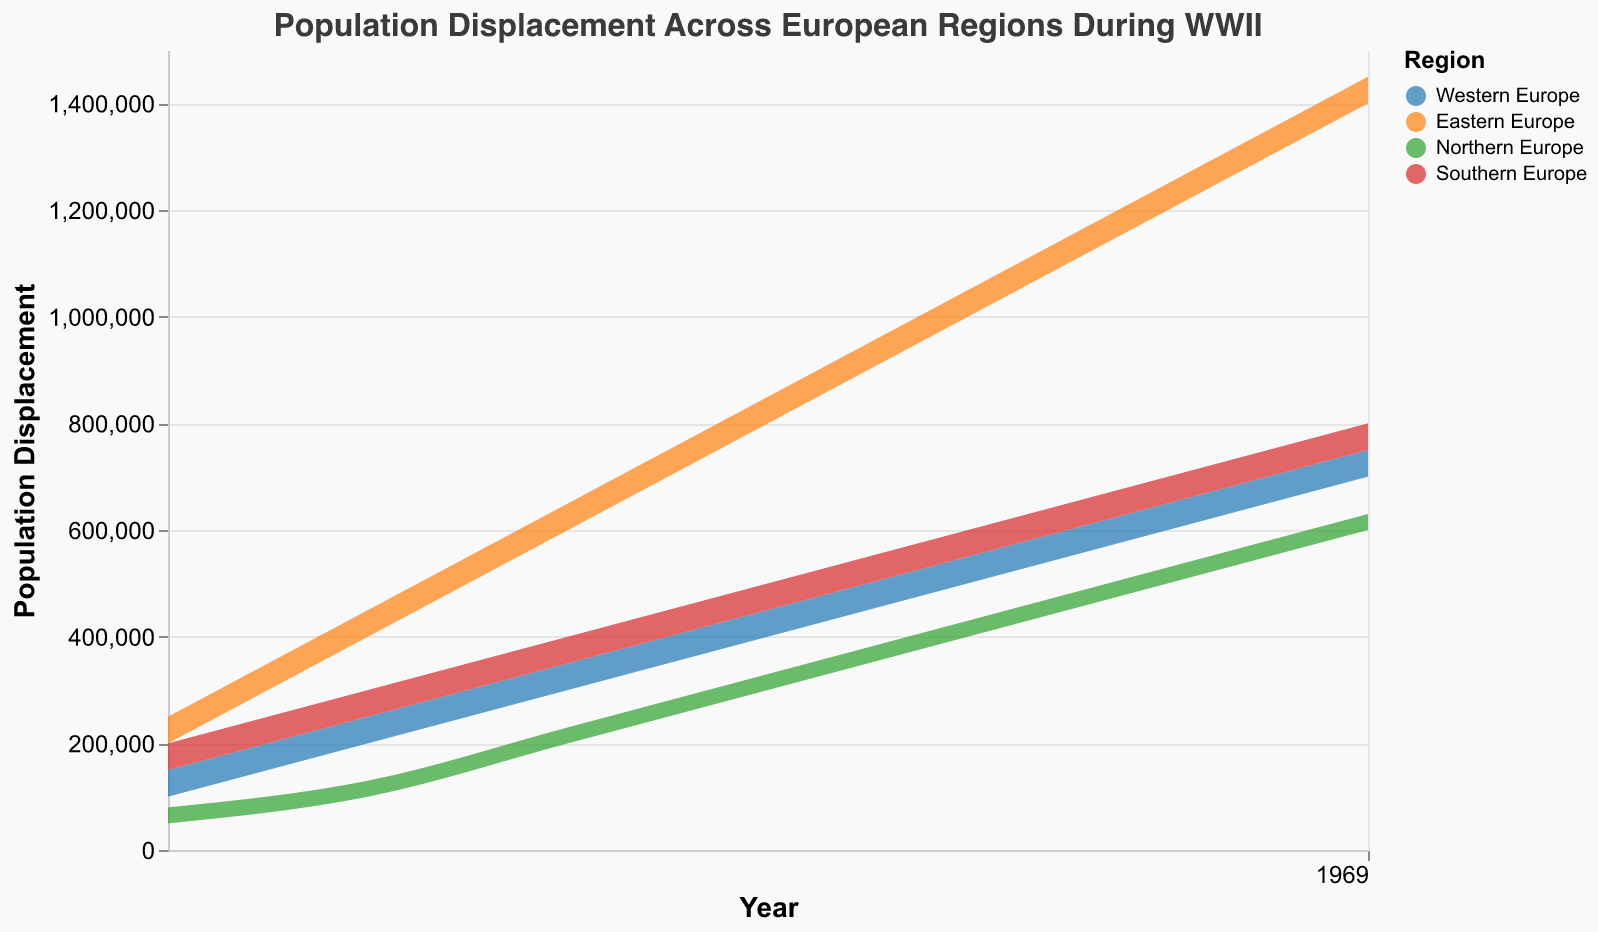What is the title of the figure? The title is usually placed at the top of the chart to give a brief description of what the chart represents. In this case, the title is "Population Displacement Across European Regions During WWII".
Answer: Population Displacement Across European Regions During WWII How many regions are represented in the chart? The color legend in the chart helps to identify the different regions represented. There are four distinct colors/regions: Western Europe, Eastern Europe, Northern Europe, and Southern Europe.
Answer: Four Which region had the highest population displacement in 1945? To determine this, we need to look at the 1945 data points for each region and compare the upper bounds of population displacement. Eastern Europe has the highest upper bound at 1,450,000.
Answer: Eastern Europe What was the population displacement range for Northern Europe in 1942? Referring to the data points for Northern Europe in 1942, the lower bound is 300,000 and the upper bound is 330,000.
Answer: 300,000 to 330,000 Which year saw the largest increase in population displacement for Western Europe? To identify the largest increase, we need to compare the displacement values year by year. The largest increase occurs between 1944 (600,000 - 650,000) and 1945 (700,000 - 750,000).
Answer: Between 1944 and 1945 By how much did the upper bound population displacement increase in Eastern Europe from 1939 to 1945? The upper bound for 1939 is 250,000 and for 1945 is 1,450,000. The increase is 1,450,000 - 250,000.
Answer: 1,200,000 What is the average lower bound population displacement for Southern Europe between 1939 to 1945? We sum the lower bound displacement values for Southern Europe for each year from 1939 to 1945 and then divide by the number of years (7). The sum is 150,000 + 250,000 + 350,000 + 450,000 + 550,000 + 650,000 + 750,000 = 3,150,000. The average is 3,150,000 / 7.
Answer: 450,000 Which region experienced the least population displacement in 1941? Comparing the data points for 1941, Northern Europe has the lowest upper bound (230,000) among all regions.
Answer: Northern Europe How did the population displacement trend for Western Europe change from 1939 to 1945? By observing the pattern in the chart, Western Europe shows a steady increase in both lower bound and upper bound displacement values from 1939 through 1945.
Answer: Steady increase Which regions' population displacement ranges overlap in 1943? Checking the data points for 1943, we see that Western Europe (500,000 - 550,000) and Southern Europe (550,000 - 600,000) have overlapping ranges.
Answer: Western Europe and Southern Europe 